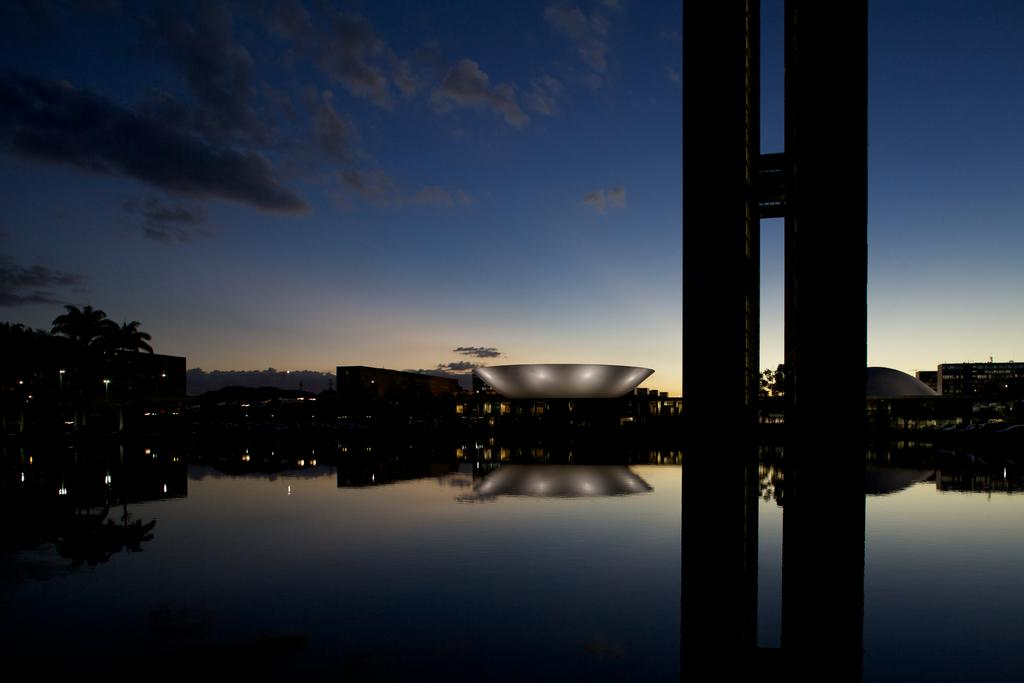What type of image is being described? The image is a landscape. What structures can be seen in the landscape? There is a building in the image. What natural elements are present in the landscape? There are trees in the image. Are there any artificial light sources visible in the image? Yes, there are lights in the image. What is the reflection of in the water in the image? The reflection of the building, trees, and lights can be seen on the water in the image. What type of yarn is being used to create the peace symbol in the image? There is no peace symbol or yarn present in the image. 